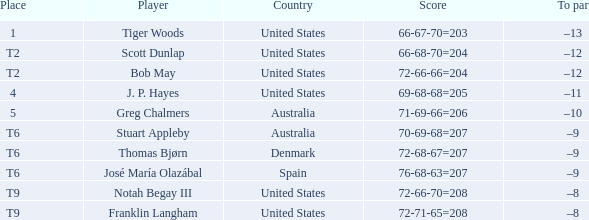What is the place of the player with a 72-71-65=208 score? T9. 